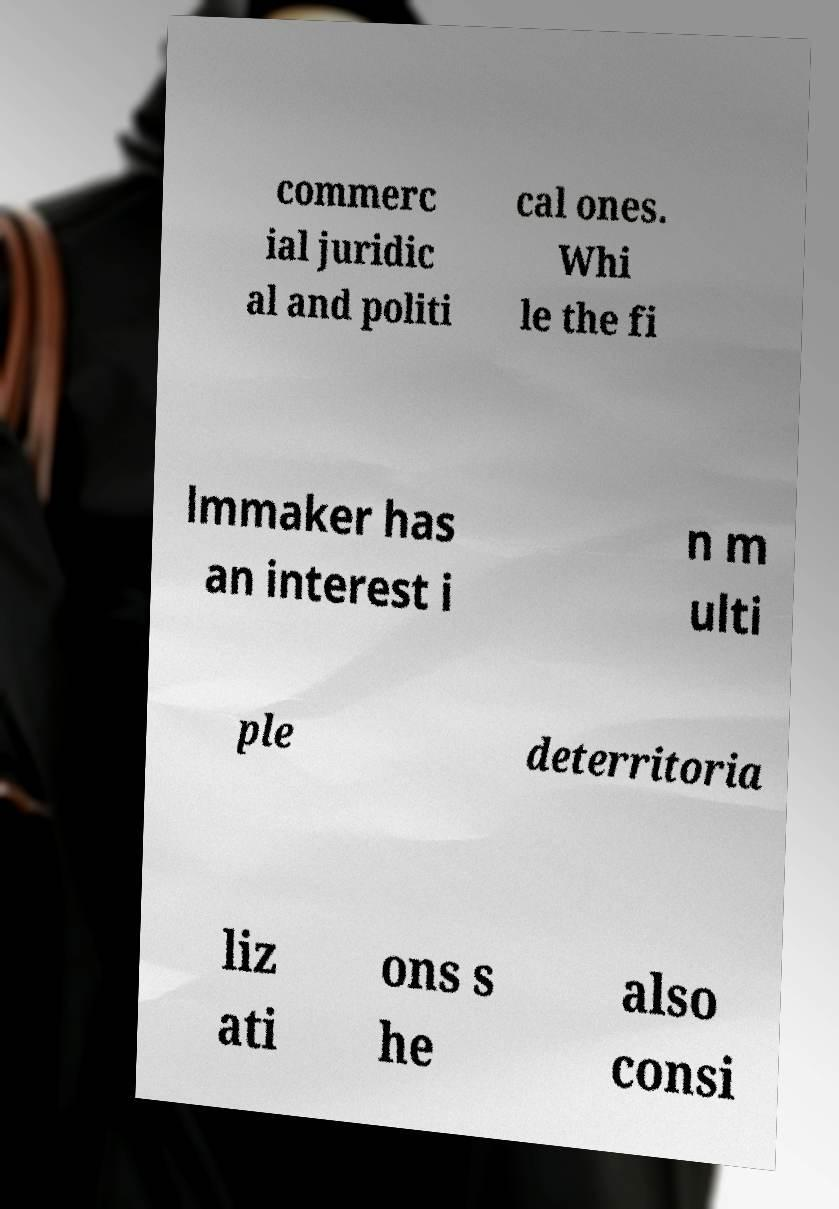What messages or text are displayed in this image? I need them in a readable, typed format. commerc ial juridic al and politi cal ones. Whi le the fi lmmaker has an interest i n m ulti ple deterritoria liz ati ons s he also consi 